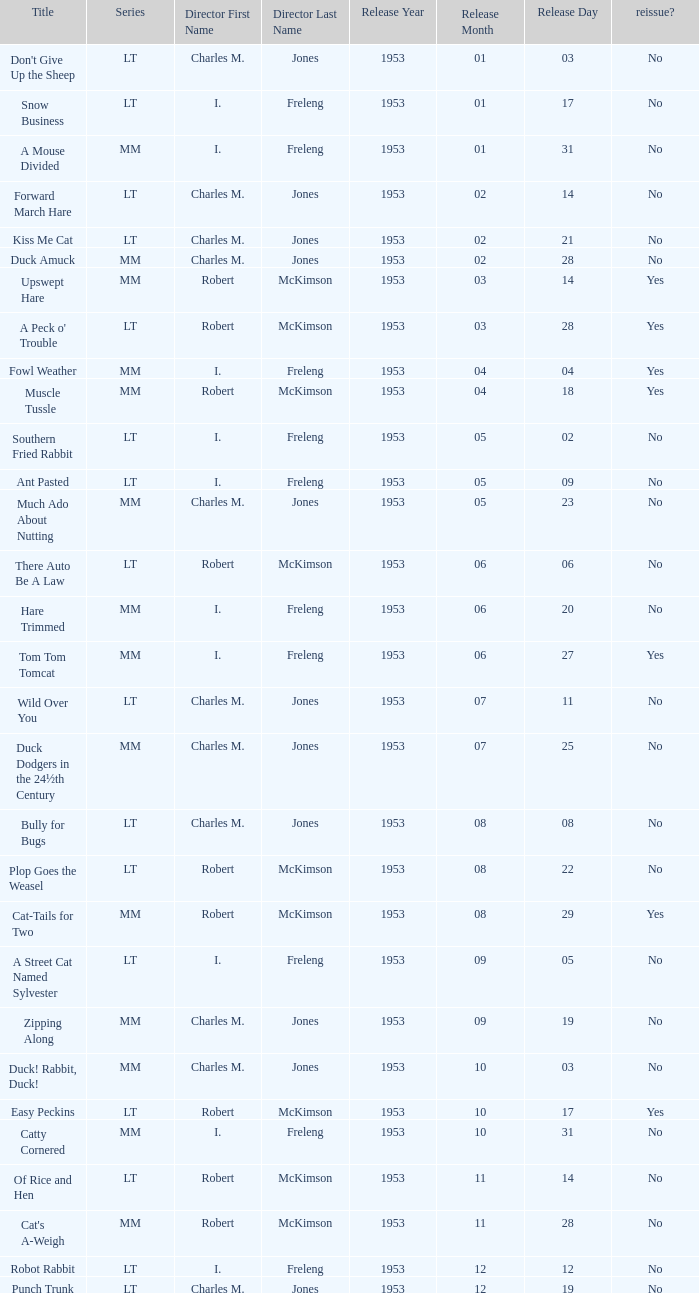Was there a reissue of the film released on 1953-10-03? No. 